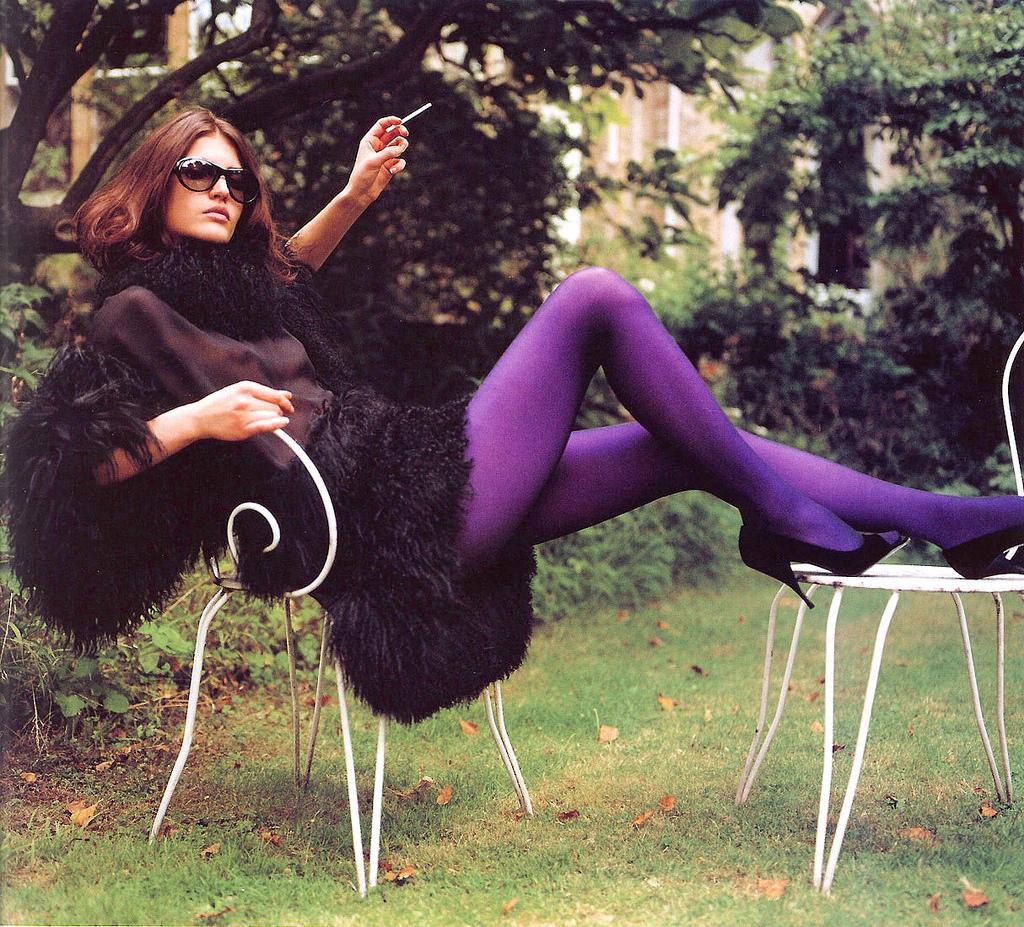Describe this image in one or two sentences. In this image, we can see a woman is sat on the chair. She wear a black color dress and blue color pant. And black color footwear. In the bottom of the image, we can see grass and dried leaves. The woman is wear goggles and she leaves her hair. She hold something in her fingers. Behind her we can see plants. The right side of the image, we can see tree and left side too. The background, we can see building. 